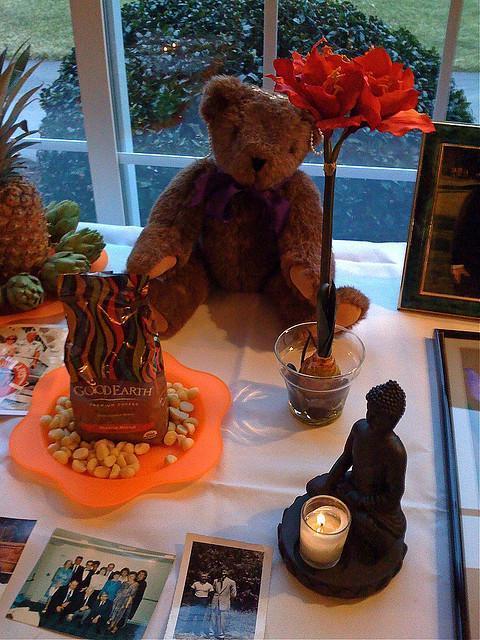Is "The teddy bear is on the dining table." an appropriate description for the image?
Answer yes or no. Yes. 